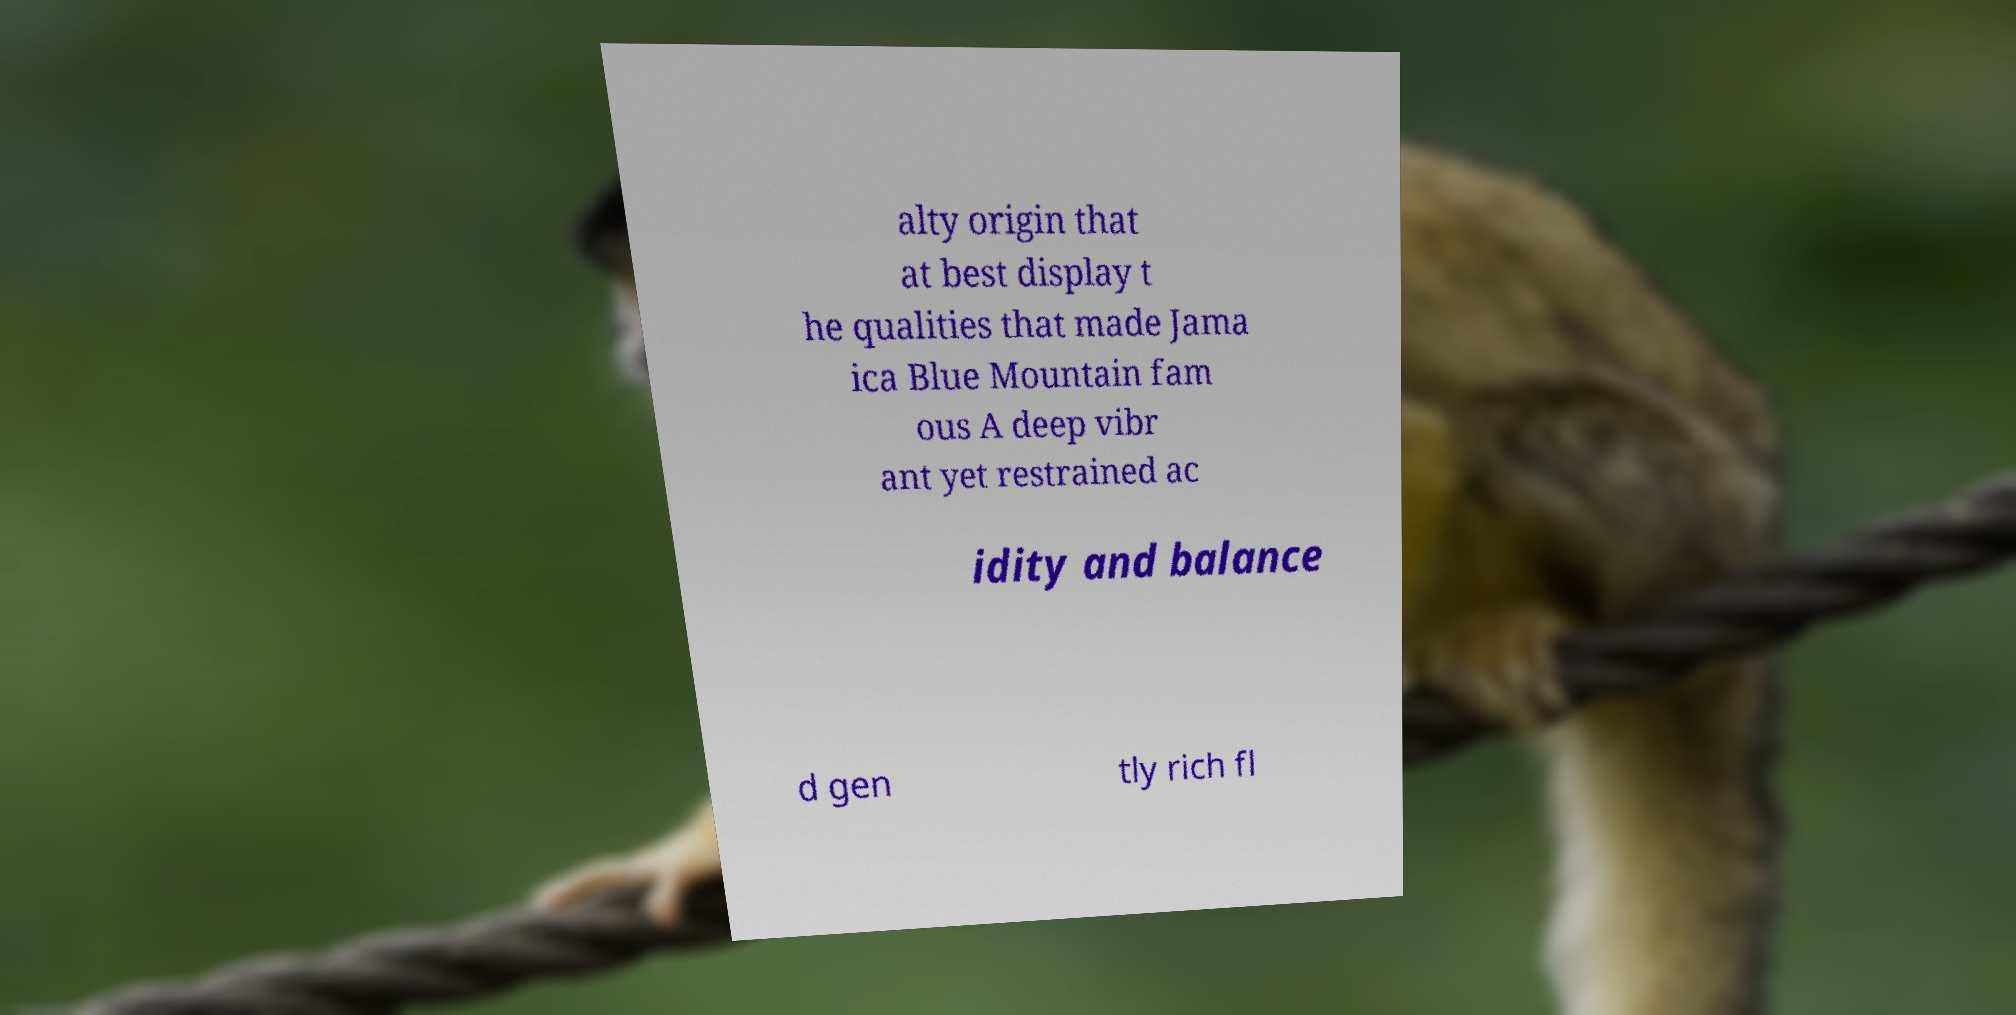Could you extract and type out the text from this image? alty origin that at best display t he qualities that made Jama ica Blue Mountain fam ous A deep vibr ant yet restrained ac idity and balance d gen tly rich fl 